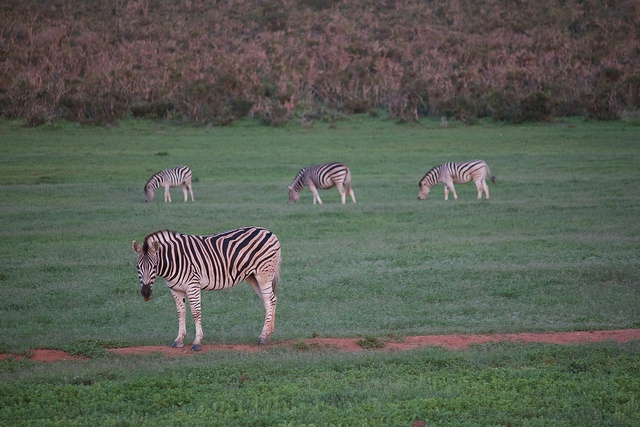Describe the objects in this image and their specific colors. I can see zebra in black, gray, darkgray, and pink tones, zebra in black, gray, darkgray, and pink tones, zebra in black, darkgray, gray, and pink tones, and zebra in black, gray, darkgray, and pink tones in this image. 